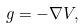<formula> <loc_0><loc_0><loc_500><loc_500>g = - \nabla V ,</formula> 